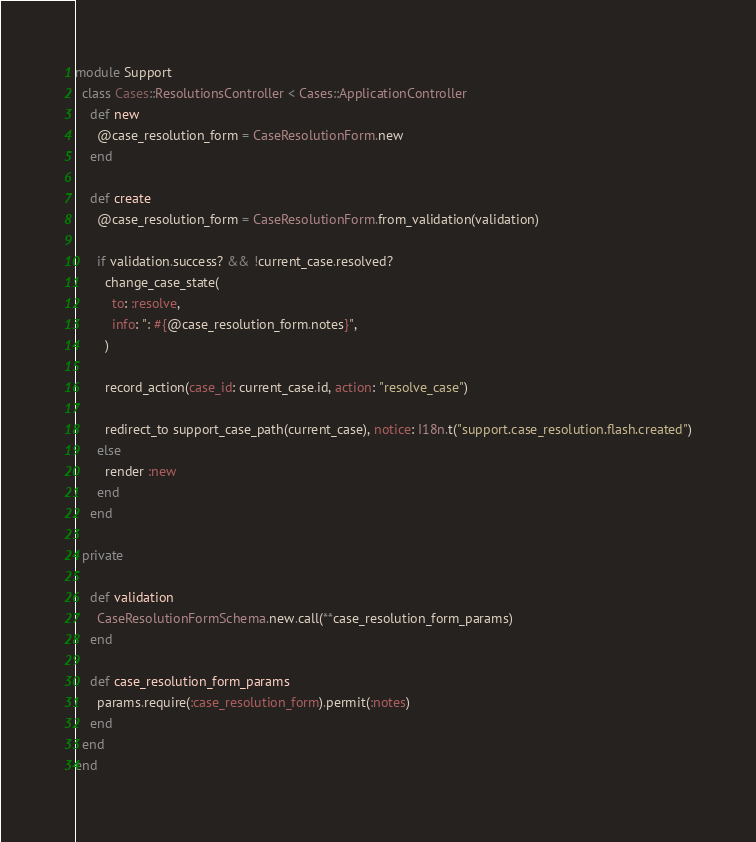Convert code to text. <code><loc_0><loc_0><loc_500><loc_500><_Ruby_>module Support
  class Cases::ResolutionsController < Cases::ApplicationController
    def new
      @case_resolution_form = CaseResolutionForm.new
    end

    def create
      @case_resolution_form = CaseResolutionForm.from_validation(validation)

      if validation.success? && !current_case.resolved?
        change_case_state(
          to: :resolve,
          info: ": #{@case_resolution_form.notes}",
        )

        record_action(case_id: current_case.id, action: "resolve_case")

        redirect_to support_case_path(current_case), notice: I18n.t("support.case_resolution.flash.created")
      else
        render :new
      end
    end

  private

    def validation
      CaseResolutionFormSchema.new.call(**case_resolution_form_params)
    end

    def case_resolution_form_params
      params.require(:case_resolution_form).permit(:notes)
    end
  end
end
</code> 